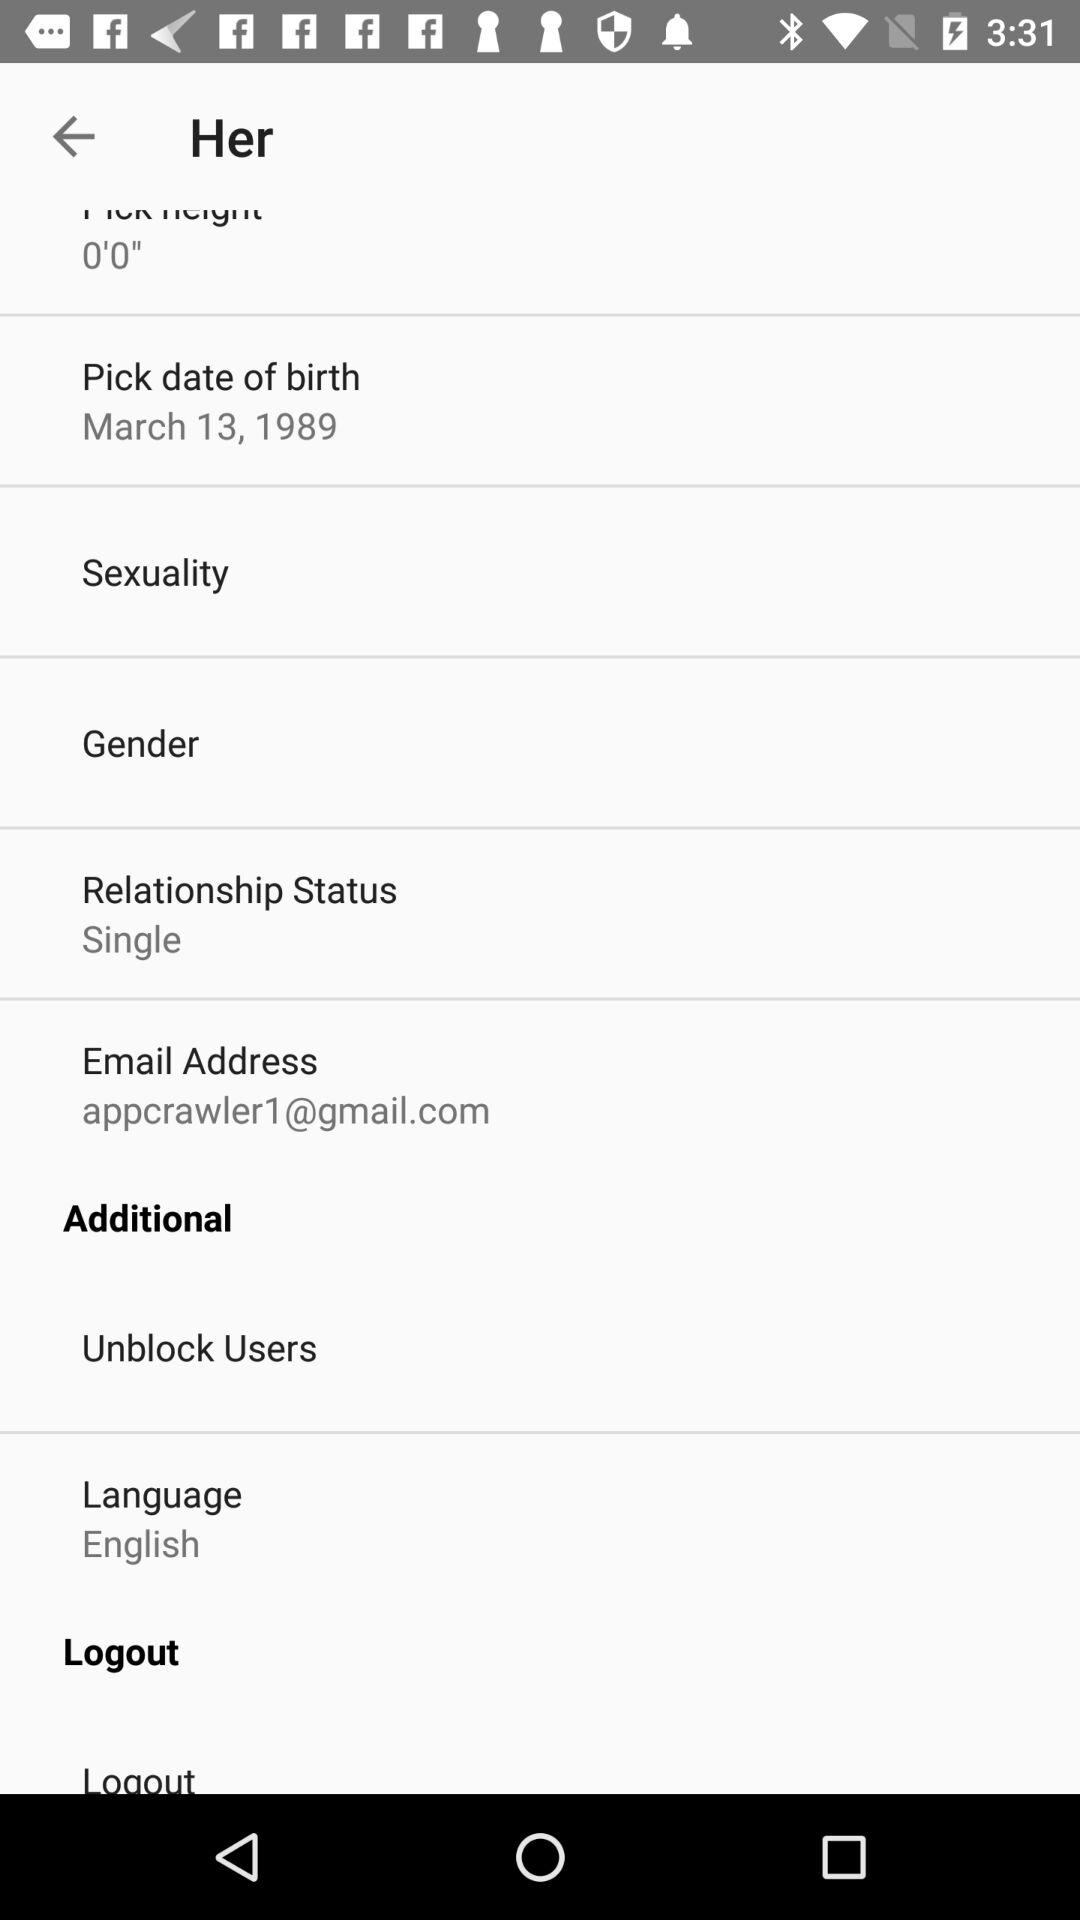What is the email address? The email address is "appcrawler1@gmail.com". 